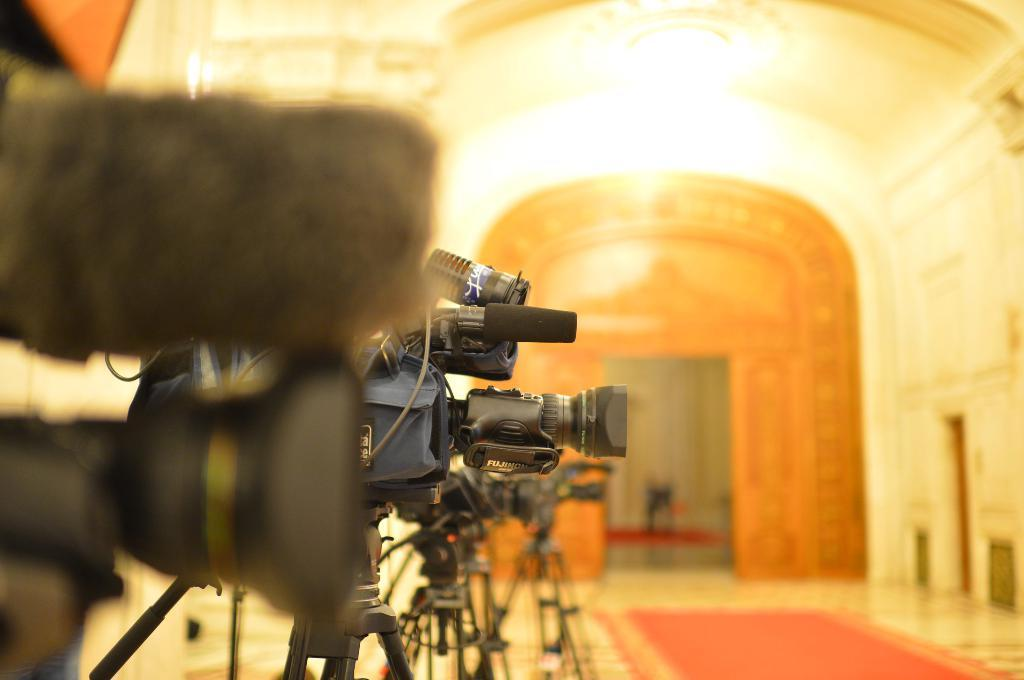What objects are present in the image related to photography? There are different types of cameras in the image. How are the cameras positioned in the image? The cameras are attached to tripods and placed on the floor. What can be seen in the background of the image? There is an arch, a chandelier, and a carpet on the floor in the background of the image. What type of fork is being used to adjust the camera settings in the image? There is no fork present in the image, and the cameras are attached to tripods, not being adjusted by hand. 